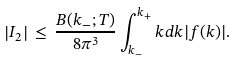<formula> <loc_0><loc_0><loc_500><loc_500>\left | I _ { 2 } \right | \, \leq \, { \frac { B ( k _ { - } ; T ) } { 8 \pi ^ { 3 } } } \int _ { k _ { - } } ^ { k _ { + } } k d k | f ( k ) | .</formula> 